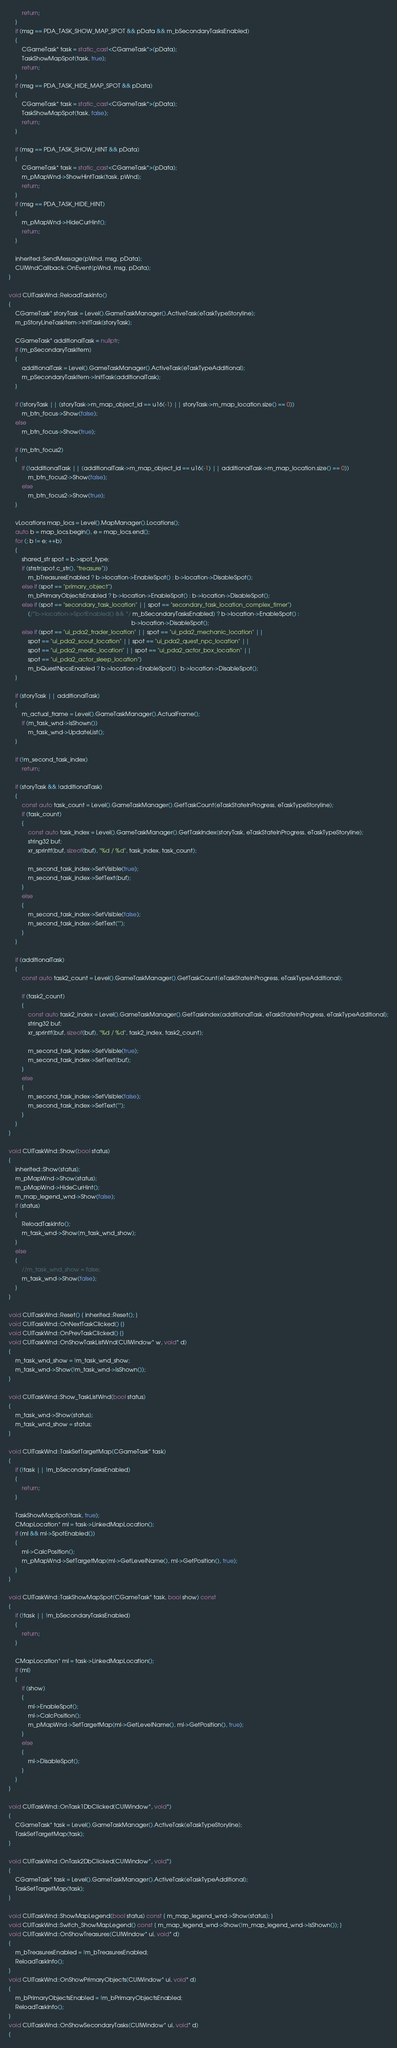<code> <loc_0><loc_0><loc_500><loc_500><_C++_>        return;
    }
    if (msg == PDA_TASK_SHOW_MAP_SPOT && pData && m_bSecondaryTasksEnabled)
    {
        CGameTask* task = static_cast<CGameTask*>(pData);
        TaskShowMapSpot(task, true);
        return;
    }
    if (msg == PDA_TASK_HIDE_MAP_SPOT && pData)
    {
        CGameTask* task = static_cast<CGameTask*>(pData);
        TaskShowMapSpot(task, false);
        return;
    }

    if (msg == PDA_TASK_SHOW_HINT && pData)
    {
        CGameTask* task = static_cast<CGameTask*>(pData);
        m_pMapWnd->ShowHintTask(task, pWnd);
        return;
    }
    if (msg == PDA_TASK_HIDE_HINT)
    {
        m_pMapWnd->HideCurHint();
        return;
    }

    inherited::SendMessage(pWnd, msg, pData);
    CUIWndCallback::OnEvent(pWnd, msg, pData);
}

void CUITaskWnd::ReloadTaskInfo()
{
    CGameTask* storyTask = Level().GameTaskManager().ActiveTask(eTaskTypeStoryline);
    m_pStoryLineTaskItem->InitTask(storyTask);

    CGameTask* additionalTask = nullptr;
    if (m_pSecondaryTaskItem)
    {
        additionalTask = Level().GameTaskManager().ActiveTask(eTaskTypeAdditional);
        m_pSecondaryTaskItem->InitTask(additionalTask);
    }

    if (!storyTask || (storyTask->m_map_object_id == u16(-1) || storyTask->m_map_location.size() == 0))
        m_btn_focus->Show(false);
    else
        m_btn_focus->Show(true);

    if (m_btn_focus2)
    {
        if (!additionalTask || (additionalTask->m_map_object_id == u16(-1) || additionalTask->m_map_location.size() == 0))
            m_btn_focus2->Show(false);
        else
            m_btn_focus2->Show(true);
    }

    vLocations map_locs = Level().MapManager().Locations();
    auto b = map_locs.begin(), e = map_locs.end();
    for (; b != e; ++b)
    {
        shared_str spot = b->spot_type;
        if (strstr(spot.c_str(), "treasure"))
            m_bTreasuresEnabled ? b->location->EnableSpot() : b->location->DisableSpot();
        else if (spot == "primary_object")
            m_bPrimaryObjectsEnabled ? b->location->EnableSpot() : b->location->DisableSpot();
        else if (spot == "secondary_task_location" || spot == "secondary_task_location_complex_timer")
            (/*b->location->SpotEnabled() && */ m_bSecondaryTasksEnabled) ? b->location->EnableSpot() :
                                                                            b->location->DisableSpot();
        else if (spot == "ui_pda2_trader_location" || spot == "ui_pda2_mechanic_location" ||
            spot == "ui_pda2_scout_location" || spot == "ui_pda2_quest_npc_location" ||
            spot == "ui_pda2_medic_location" || spot == "ui_pda2_actor_box_location" ||
            spot == "ui_pda2_actor_sleep_location")
            m_bQuestNpcsEnabled ? b->location->EnableSpot() : b->location->DisableSpot();
    }

    if (storyTask || additionalTask)
    {
        m_actual_frame = Level().GameTaskManager().ActualFrame();
        if (m_task_wnd->IsShown())
            m_task_wnd->UpdateList();
    }

    if (!m_second_task_index)
        return;

    if (storyTask && !additionalTask)
    {
        const auto task_count = Level().GameTaskManager().GetTaskCount(eTaskStateInProgress, eTaskTypeStoryline);
        if (task_count)
        {
            const auto task_index = Level().GameTaskManager().GetTaskIndex(storyTask, eTaskStateInProgress, eTaskTypeStoryline);
            string32 buf;
            xr_sprintf(buf, sizeof(buf), "%d / %d", task_index, task_count);

            m_second_task_index->SetVisible(true);
            m_second_task_index->SetText(buf);
        }
        else
        {
            m_second_task_index->SetVisible(false);
            m_second_task_index->SetText("");
        }
    }

    if (additionalTask)
    {
        const auto task2_count = Level().GameTaskManager().GetTaskCount(eTaskStateInProgress, eTaskTypeAdditional);

        if (task2_count)
        {
            const auto task2_index = Level().GameTaskManager().GetTaskIndex(additionalTask, eTaskStateInProgress, eTaskTypeAdditional);
            string32 buf;
            xr_sprintf(buf, sizeof(buf), "%d / %d", task2_index, task2_count);

            m_second_task_index->SetVisible(true);
            m_second_task_index->SetText(buf);
        }
        else
        {
            m_second_task_index->SetVisible(false);
            m_second_task_index->SetText("");
        }
    }
}

void CUITaskWnd::Show(bool status)
{
    inherited::Show(status);
    m_pMapWnd->Show(status);
    m_pMapWnd->HideCurHint();
    m_map_legend_wnd->Show(false);
    if (status)
    {
        ReloadTaskInfo();
        m_task_wnd->Show(m_task_wnd_show);
    }
    else
    {
        //m_task_wnd_show = false;
        m_task_wnd->Show(false);
    }
}

void CUITaskWnd::Reset() { inherited::Reset(); }
void CUITaskWnd::OnNextTaskClicked() {}
void CUITaskWnd::OnPrevTaskClicked() {}
void CUITaskWnd::OnShowTaskListWnd(CUIWindow* w, void* d)
{
    m_task_wnd_show = !m_task_wnd_show;
    m_task_wnd->Show(!m_task_wnd->IsShown());
}

void CUITaskWnd::Show_TaskListWnd(bool status)
{
    m_task_wnd->Show(status);
    m_task_wnd_show = status;
}

void CUITaskWnd::TaskSetTargetMap(CGameTask* task)
{
    if (!task || !m_bSecondaryTasksEnabled)
    {
        return;
    }

    TaskShowMapSpot(task, true);
    CMapLocation* ml = task->LinkedMapLocation();
    if (ml && ml->SpotEnabled())
    {
        ml->CalcPosition();
        m_pMapWnd->SetTargetMap(ml->GetLevelName(), ml->GetPosition(), true);
    }
}

void CUITaskWnd::TaskShowMapSpot(CGameTask* task, bool show) const
{
    if (!task || !m_bSecondaryTasksEnabled)
    {
        return;
    }

    CMapLocation* ml = task->LinkedMapLocation();
    if (ml)
    {
        if (show)
        {
            ml->EnableSpot();
            ml->CalcPosition();
            m_pMapWnd->SetTargetMap(ml->GetLevelName(), ml->GetPosition(), true);
        }
        else
        {
            ml->DisableSpot();
        }
    }
}

void CUITaskWnd::OnTask1DbClicked(CUIWindow*, void*)
{
    CGameTask* task = Level().GameTaskManager().ActiveTask(eTaskTypeStoryline);
    TaskSetTargetMap(task);
}

void CUITaskWnd::OnTask2DbClicked(CUIWindow*, void*)
{
    CGameTask* task = Level().GameTaskManager().ActiveTask(eTaskTypeAdditional);
    TaskSetTargetMap(task);
}

void CUITaskWnd::ShowMapLegend(bool status) const { m_map_legend_wnd->Show(status); }
void CUITaskWnd::Switch_ShowMapLegend() const { m_map_legend_wnd->Show(!m_map_legend_wnd->IsShown()); }
void CUITaskWnd::OnShowTreasures(CUIWindow* ui, void* d)
{
    m_bTreasuresEnabled = !m_bTreasuresEnabled;
    ReloadTaskInfo();
}
void CUITaskWnd::OnShowPrimaryObjects(CUIWindow* ui, void* d)
{
    m_bPrimaryObjectsEnabled = !m_bPrimaryObjectsEnabled;
    ReloadTaskInfo();
}
void CUITaskWnd::OnShowSecondaryTasks(CUIWindow* ui, void* d)
{</code> 